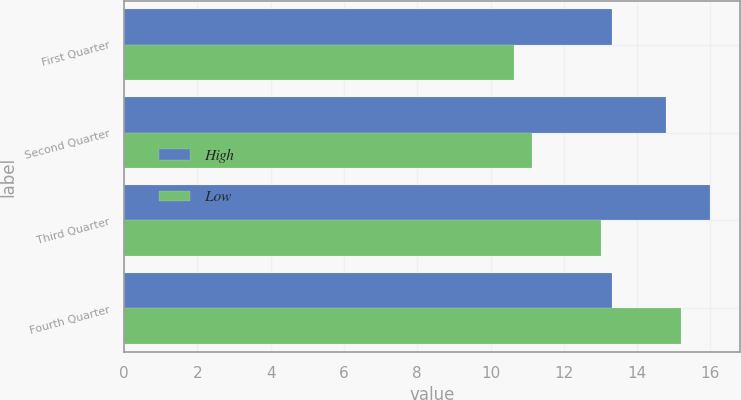Convert chart. <chart><loc_0><loc_0><loc_500><loc_500><stacked_bar_chart><ecel><fcel>First Quarter<fcel>Second Quarter<fcel>Third Quarter<fcel>Fourth Quarter<nl><fcel>High<fcel>13.32<fcel>14.8<fcel>16<fcel>13.32<nl><fcel>Low<fcel>10.64<fcel>11.14<fcel>13.02<fcel>15.2<nl></chart> 